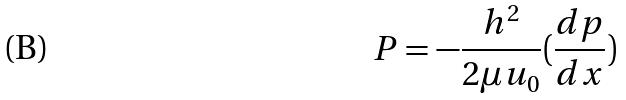Convert formula to latex. <formula><loc_0><loc_0><loc_500><loc_500>P = - \frac { h ^ { 2 } } { 2 \mu u _ { 0 } } ( \frac { d p } { d x } )</formula> 